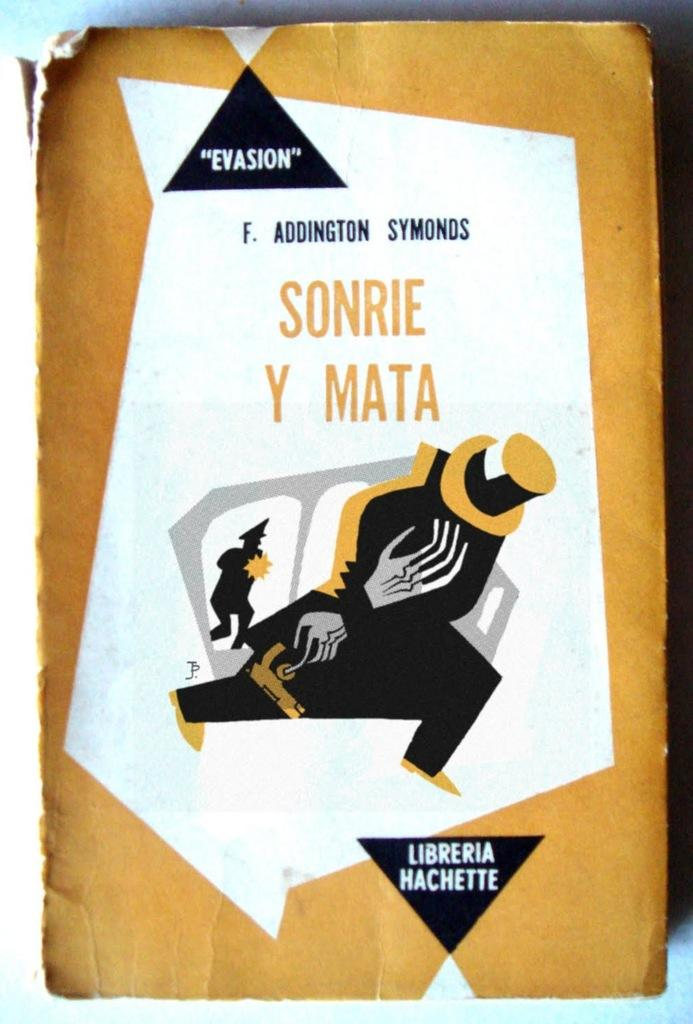<image>
Give a short and clear explanation of the subsequent image. A yellow. white and black book cover says Sonrie Y Mata. 